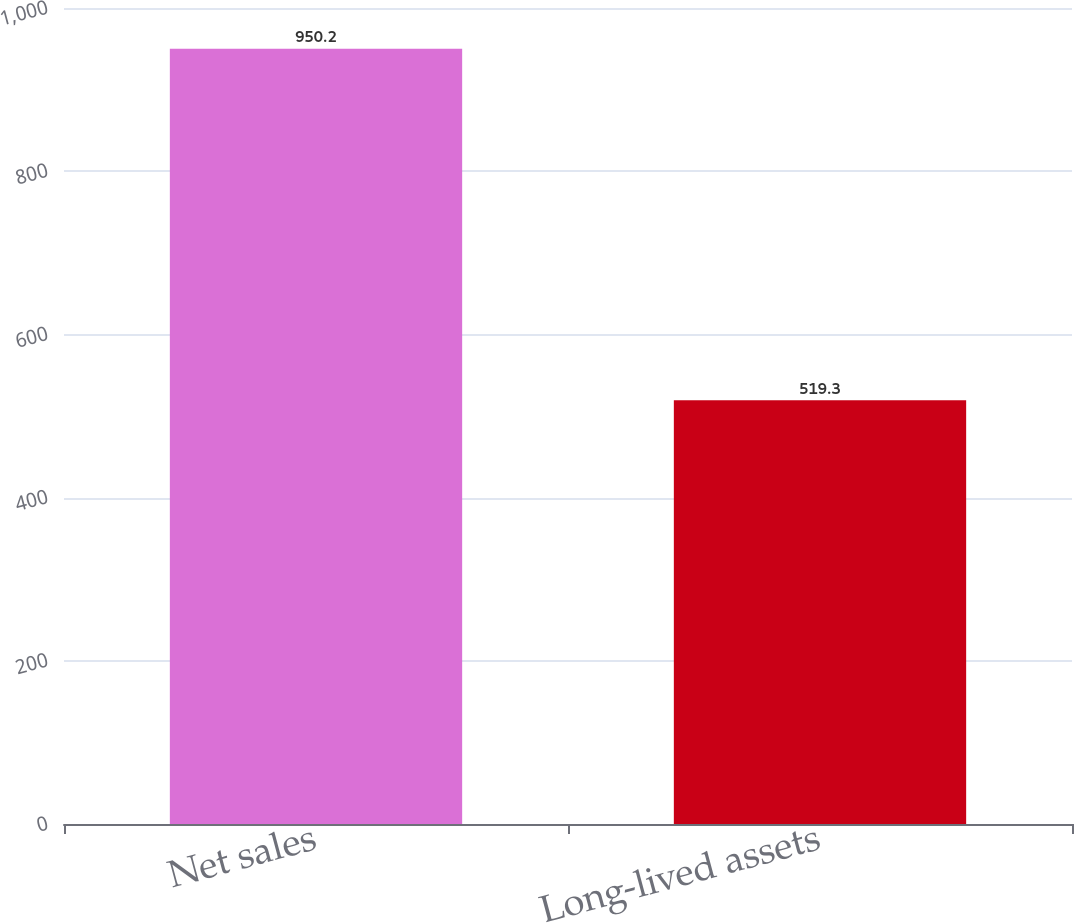<chart> <loc_0><loc_0><loc_500><loc_500><bar_chart><fcel>Net sales<fcel>Long-lived assets<nl><fcel>950.2<fcel>519.3<nl></chart> 